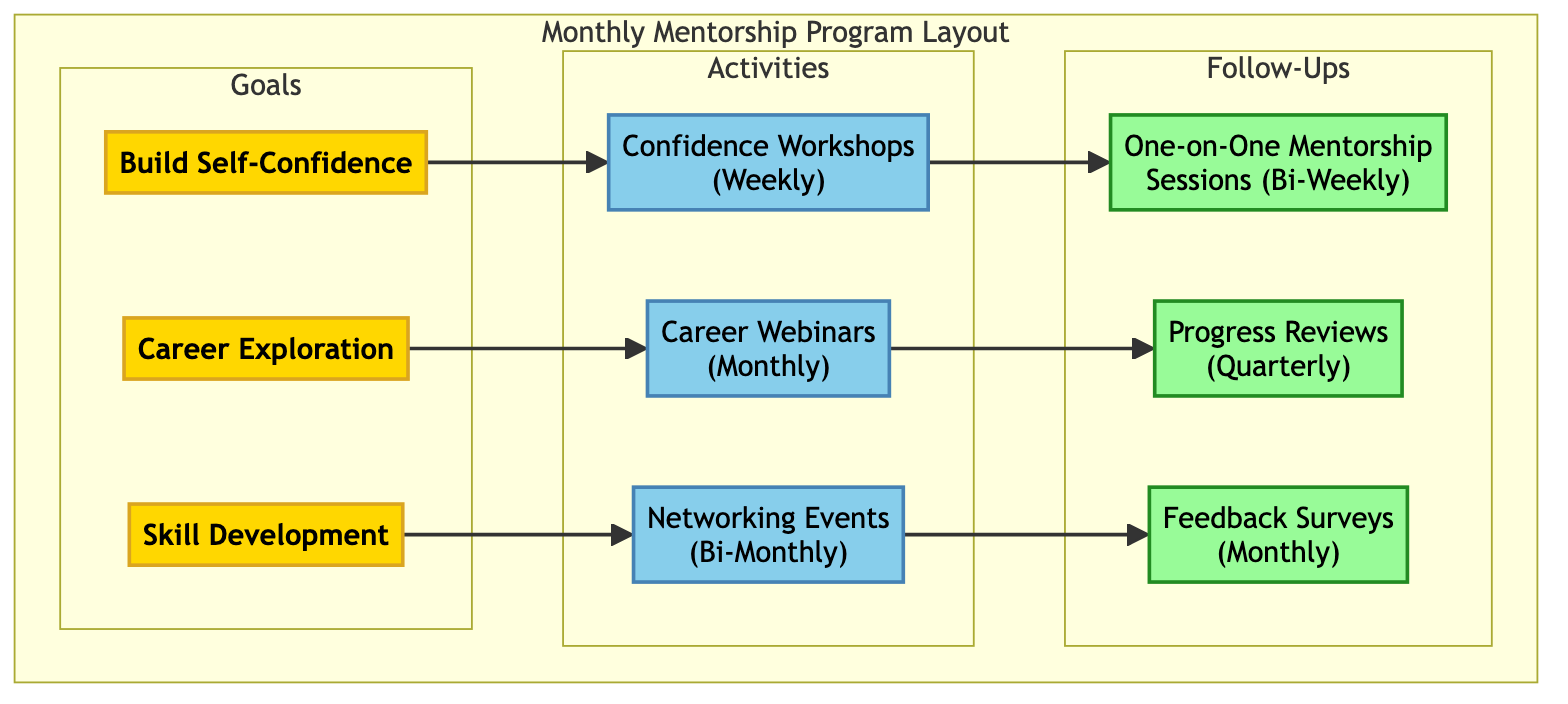What are the three main goals of the program? The diagram indicates three main goals listed under the "Goals" section: "Build Self-Confidence," "Career Exploration," and "Skill Development."
Answer: Build Self-Confidence, Career Exploration, Skill Development How frequently are Confidence Workshops held? The "Activities" section shows that Confidence Workshops are scheduled "Weekly," indicating that these sessions occur once a week.
Answer: Weekly Which follow-up activity occurs quarterly? Under the "Follow-Ups" section, "Progress Reviews" is specified as a quarterly activity, meaning it happens every three months.
Answer: Progress Reviews How many activities are connected to the goal of Skill Development? The diagram flows from the goal of Skill Development to one specific activity, "Networking Events," indicating that this is the only activity associated with this goal.
Answer: One What is the relationship between Career Webinars and Feedback Surveys? The flow from "Career Webinars" leads to "Progress Reviews," but there is no direct connection to "Feedback Surveys;" the latter connects to other activities, implying they are related to different goals.
Answer: No direct relationship How many total follow-up activities are there? The diagram lists three follow-up activities in the "Follow-Ups" section: "One-on-One Mentorship Sessions," "Progress Reviews," and "Feedback Surveys." Therefore, the total count is three.
Answer: Three Which activity related to Building Self-Confidence includes public speaking practice? The "Activities" section highlights "Confidence Workshops," which specifically mentions exercises aimed at boosting self-esteem and improving public speaking skills.
Answer: Confidence Workshops What type of events are Networking Events? The description in the "Activities" section categorizes Networking Events as either virtual or in-person, indicating the format of these activities.
Answer: Virtual or in-person How often are One-on-One Mentorship Sessions conducted? The "Follow-Ups" section describes One-on-One Mentorship Sessions as occurring "Bi-Weekly," which means they take place every two weeks.
Answer: Bi-Weekly 